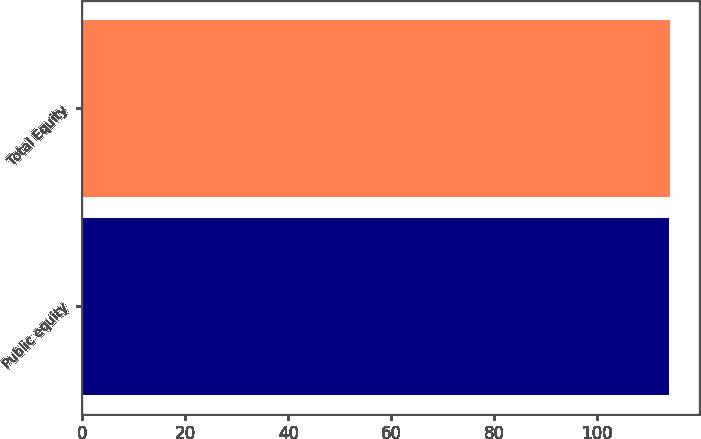Convert chart to OTSL. <chart><loc_0><loc_0><loc_500><loc_500><bar_chart><fcel>Public equity<fcel>Total Equity<nl><fcel>114<fcel>114.1<nl></chart> 